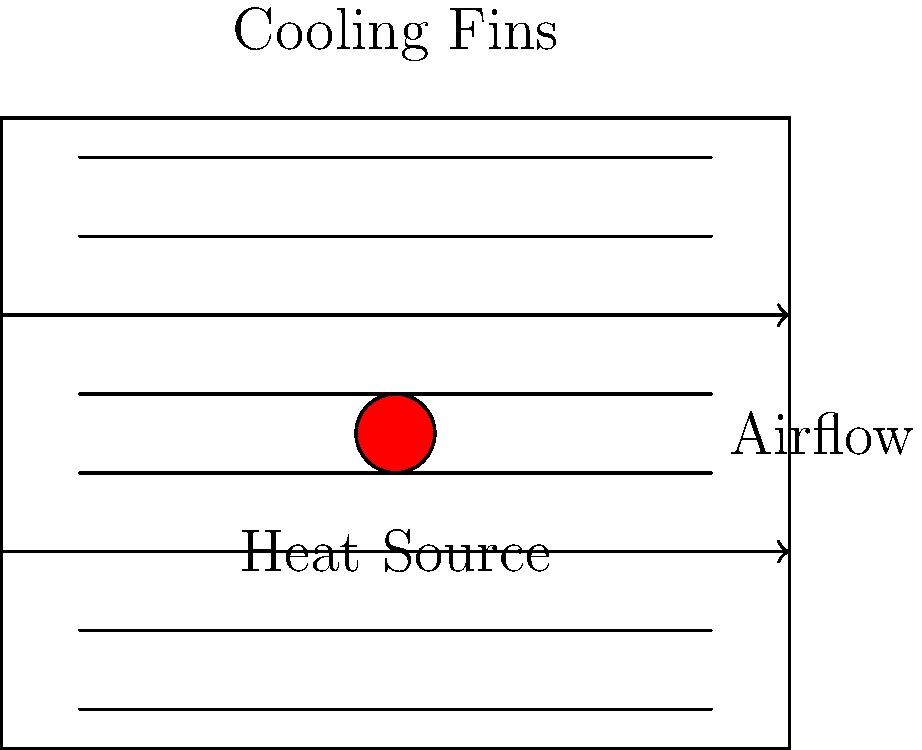In the design of a 5G base station with multiple cooling fins, you notice that your competitor Huawei has implemented a new heat dissipation system. The system uses 8 equally spaced cooling fins with a central heat source. If the thermal conductivity of the fin material is $k = 200 \text{ W/(m·K)}$, the fin thickness is $t = 2 \text{ mm}$, the fin length is $L = 100 \text{ mm}$, and the temperature difference between the base and the ambient air is $\Delta T = 40 \text{ K}$, what is the approximate heat dissipation rate for a single fin? Assume the fin can be treated as a straight rectangular fin with an adiabatic tip. To solve this problem, we'll use the equation for heat dissipation from a straight rectangular fin with an adiabatic tip:

1) The heat dissipation rate for a single fin is given by:

   $Q = \sqrt{h P k A_c} \cdot \Delta T \cdot \tanh(mL)$

   Where:
   $h$ = convection heat transfer coefficient (assume $h = 50 \text{ W/(m²·K)}$ for forced air cooling)
   $P$ = fin perimeter
   $k$ = thermal conductivity of the fin material
   $A_c$ = cross-sectional area of the fin
   $\Delta T$ = temperature difference between the base and ambient air
   $L$ = fin length
   $m$ = $\sqrt{\frac{hP}{kA_c}}$

2) Calculate the fin perimeter:
   $P = 2(t + w)$, where $w$ is the fin width (assume $w = 50 \text{ mm}$)
   $P = 2(0.002 + 0.05) = 0.104 \text{ m}$

3) Calculate the cross-sectional area:
   $A_c = t \cdot w = 0.002 \cdot 0.05 = 1 \times 10^{-4} \text{ m²}$

4) Calculate $m$:
   $m = \sqrt{\frac{50 \cdot 0.104}{200 \cdot 1 \times 10^{-4}}} = 16.12 \text{ m}^{-1}$

5) Calculate $mL$:
   $mL = 16.12 \cdot 0.1 = 1.612$

6) Now we can calculate the heat dissipation rate:
   $Q = \sqrt{50 \cdot 0.104 \cdot 200 \cdot 1 \times 10^{-4}} \cdot 40 \cdot \tanh(1.612)$
   $Q = 0.3225 \cdot 40 \cdot 0.9241 = 11.92 \text{ W}$

Therefore, the approximate heat dissipation rate for a single fin is 11.92 W.
Answer: 11.92 W 